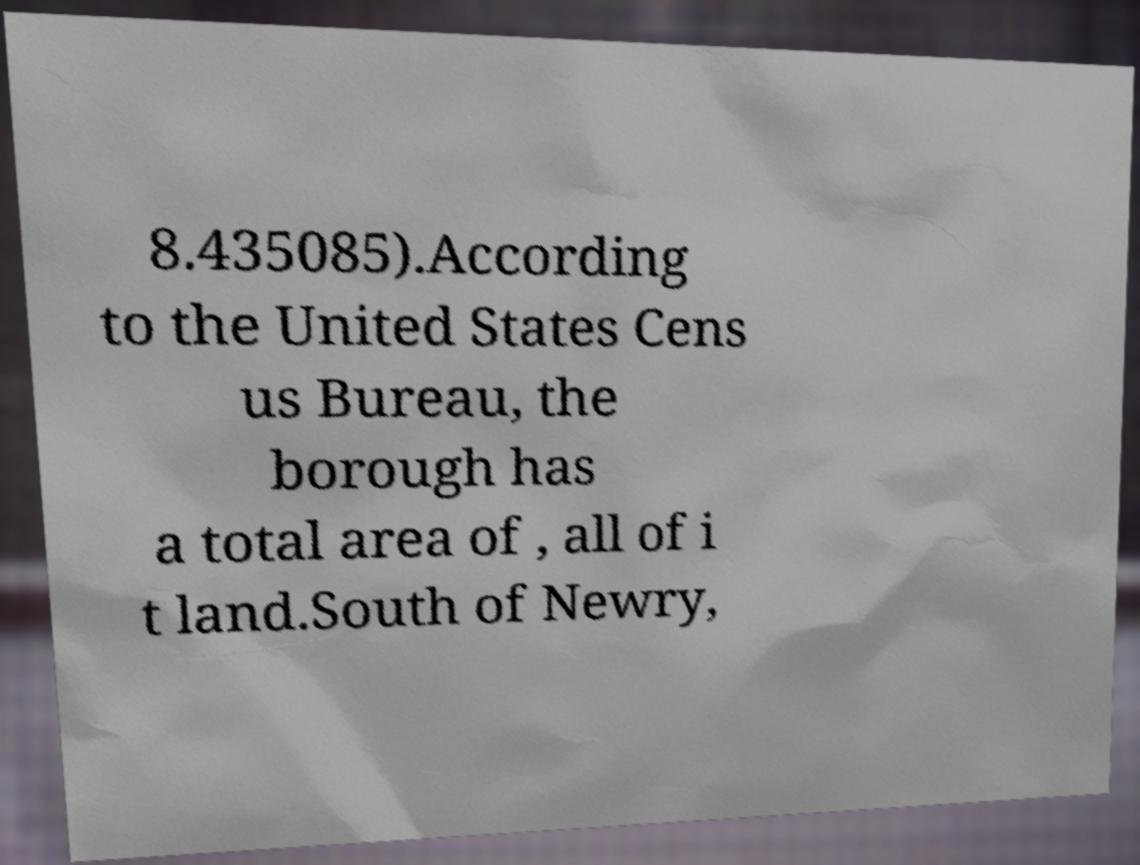Can you read and provide the text displayed in the image?This photo seems to have some interesting text. Can you extract and type it out for me? 8.435085).According to the United States Cens us Bureau, the borough has a total area of , all of i t land.South of Newry, 